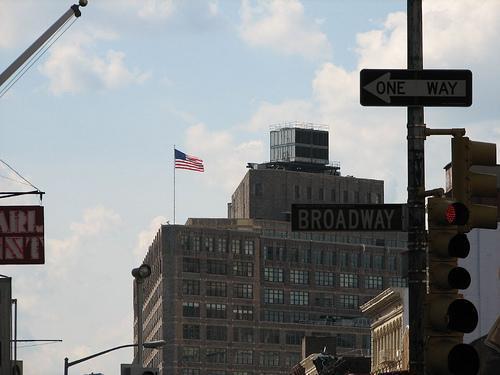How many flags are there?
Give a very brief answer. 1. 